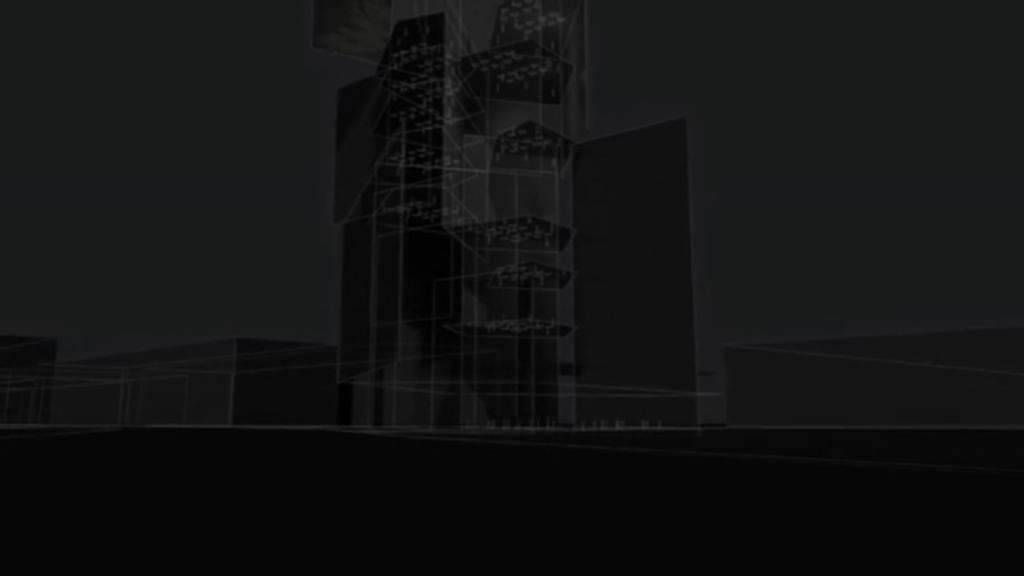In one or two sentences, can you explain what this image depicts? In this image we can see buildings with graphical effect. And the image is looking dark. 